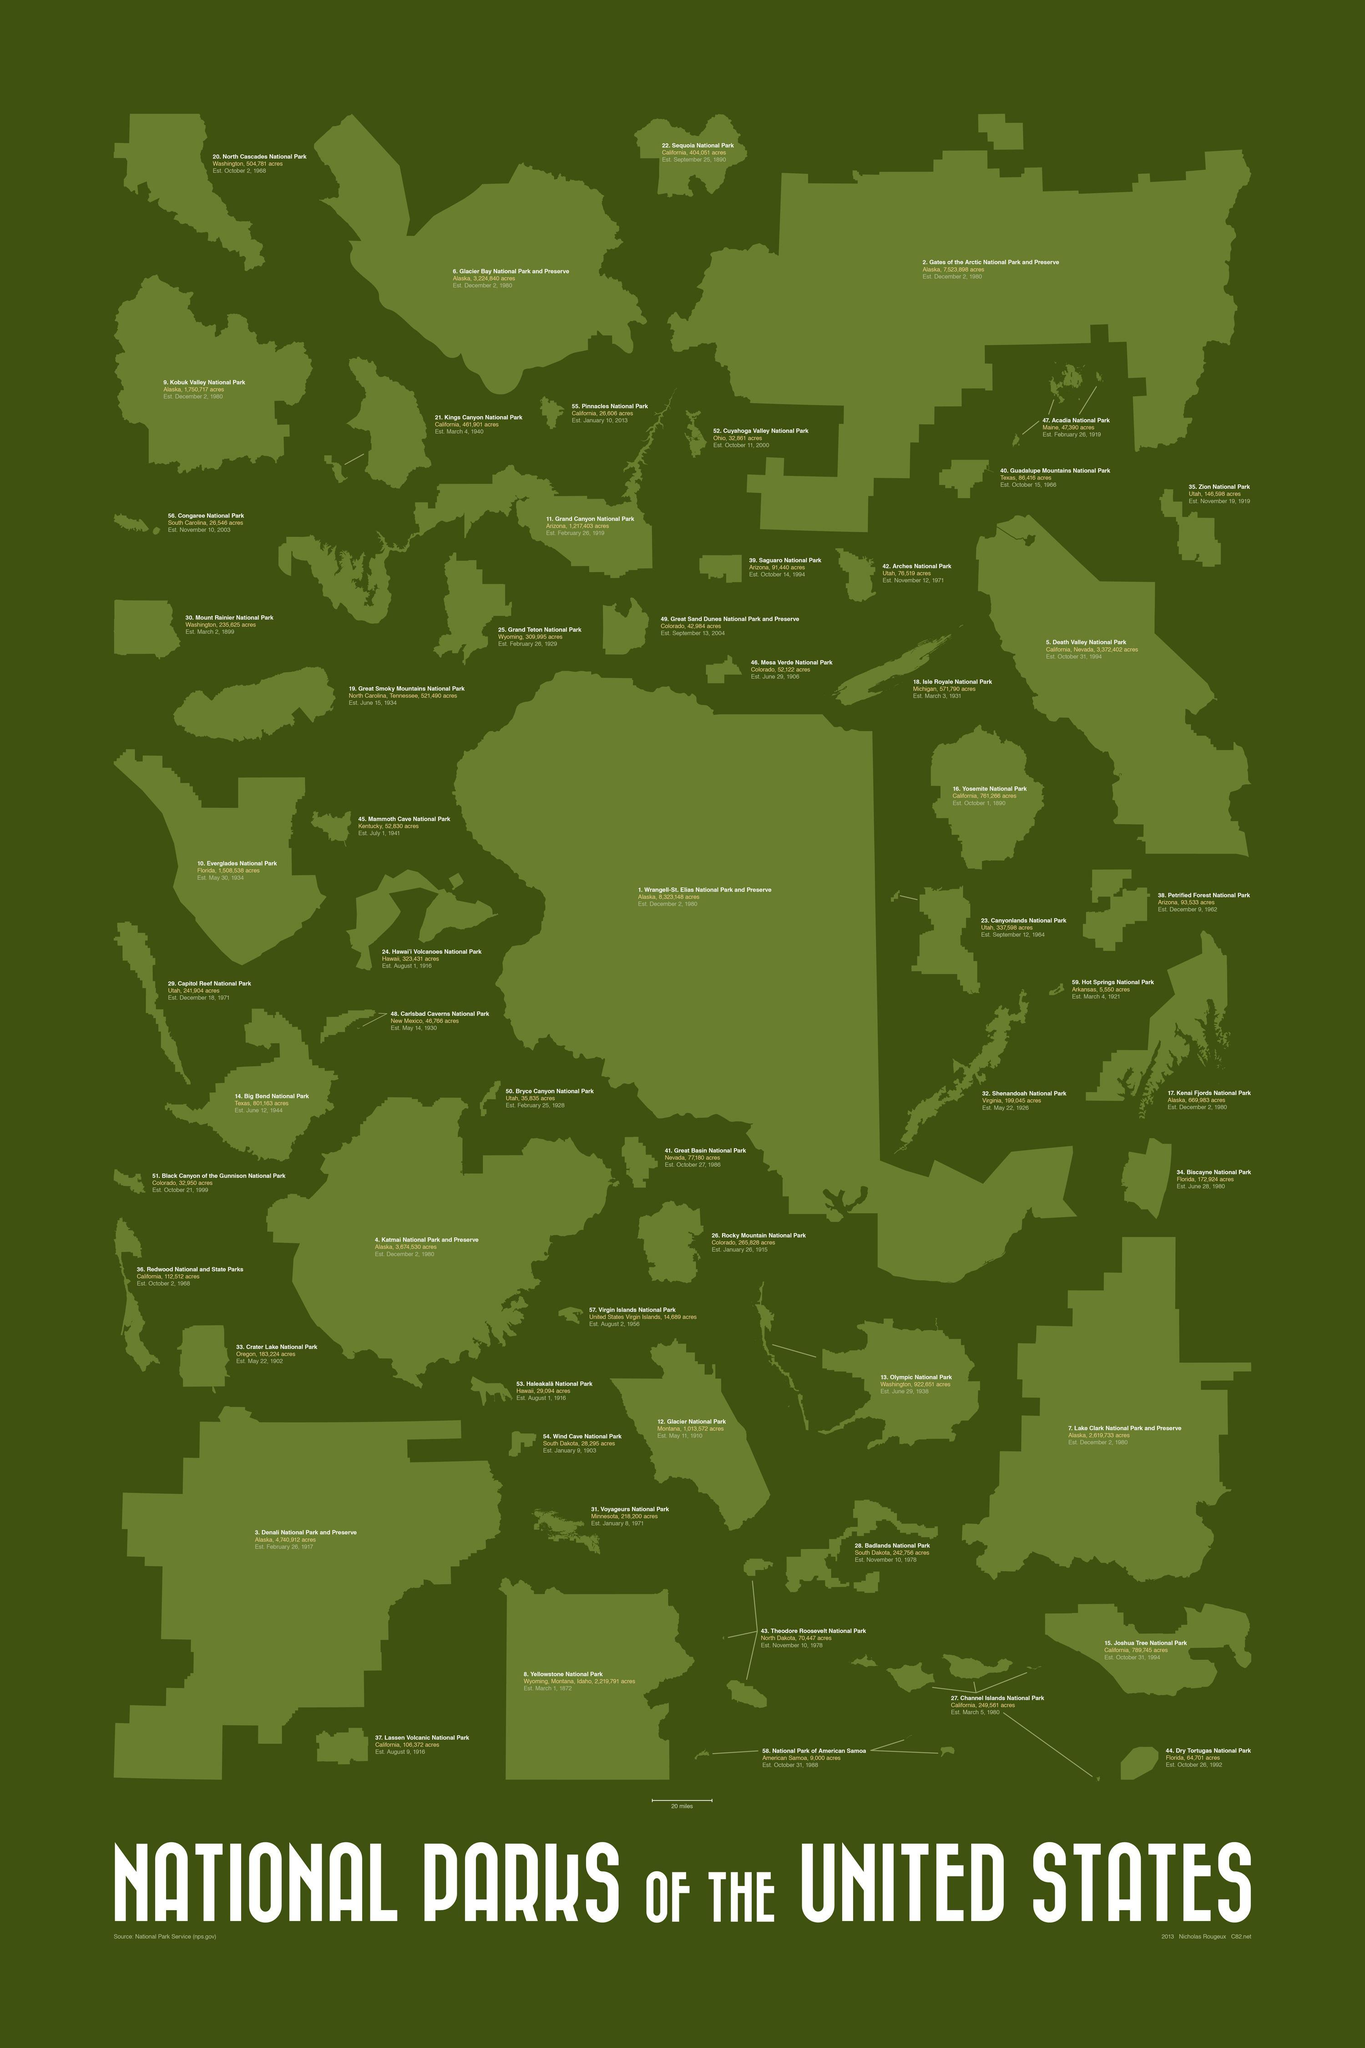Where is Olympic National Park Located?
Answer the question with a short phrase. Washington Which national park was established on March 4, 1940? Kings Canyon National Park On which year did Rocky Mountain National Park was established? January 26, 1915 On which year Grand Teton National Park was established? 1929 Where is the location of Rocky Mountain National Park? Colorado On which year did Death Valley National Park was established? 1994 On which year North Cascades National Park was established? 1968 Which National Park was established on August 9, 1916? Lassen Volcanic National Park On which year did Badlands National Park was established? November 10, 1978 What is the area of Katmal National Park and Reserve? 3,674,530 acres 